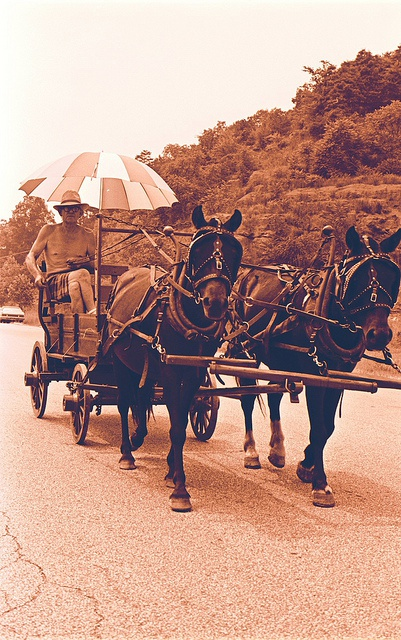Describe the objects in this image and their specific colors. I can see horse in white, navy, purple, brown, and black tones, horse in white, black, purple, and brown tones, umbrella in white, tan, and salmon tones, people in white, brown, salmon, and purple tones, and car in white, tan, and brown tones in this image. 